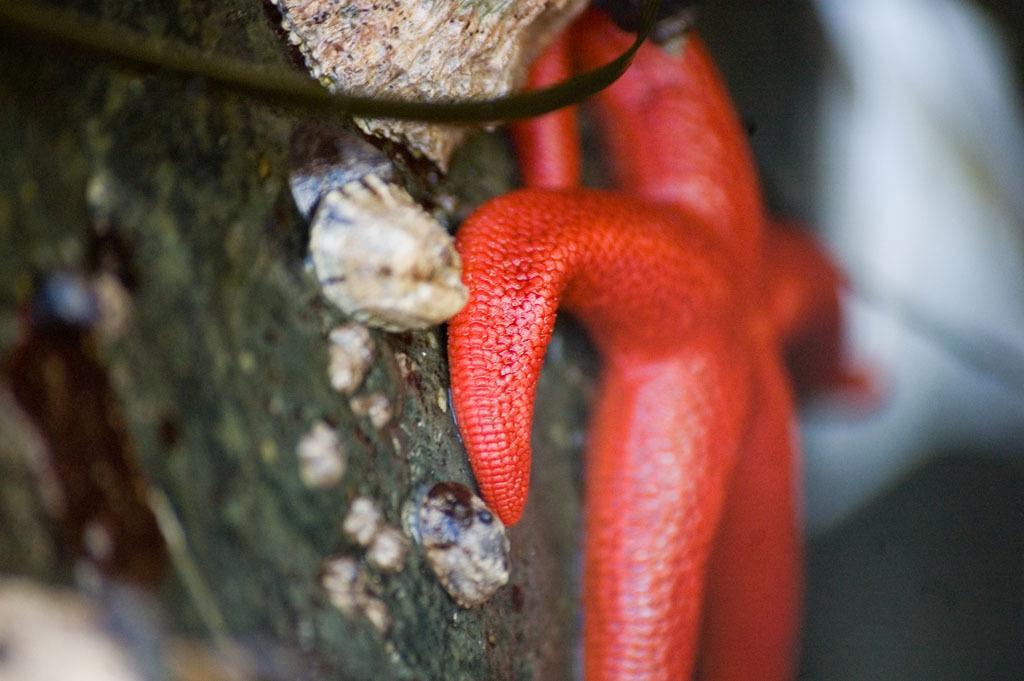Could you give a brief overview of what you see in this image? There is a red color starfish on a surface. And the background is blurred. 